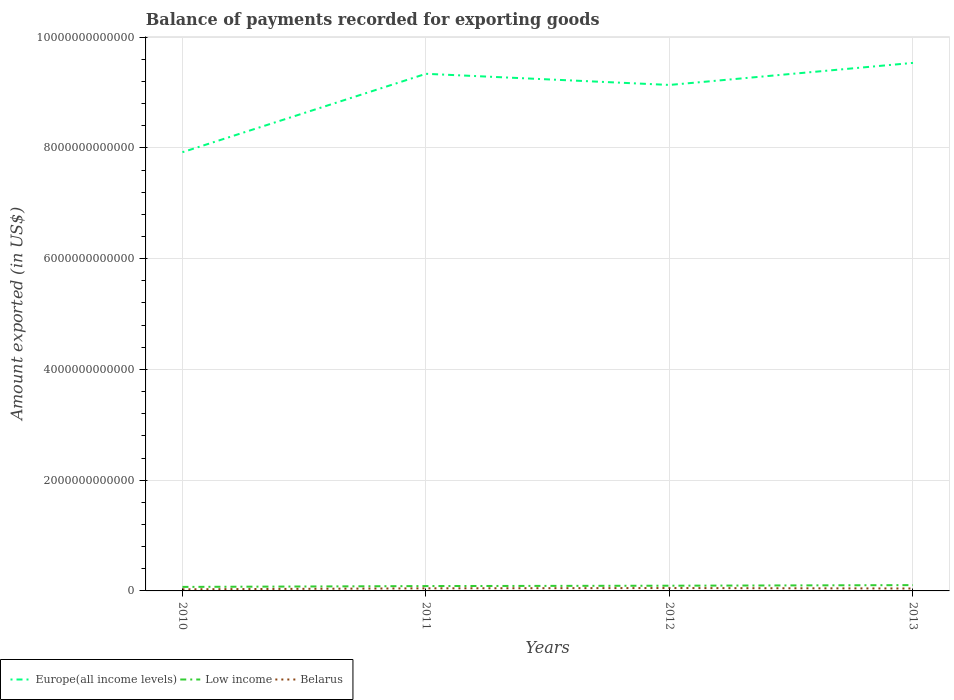How many different coloured lines are there?
Offer a very short reply. 3. Does the line corresponding to Low income intersect with the line corresponding to Europe(all income levels)?
Make the answer very short. No. Is the number of lines equal to the number of legend labels?
Make the answer very short. Yes. Across all years, what is the maximum amount exported in Europe(all income levels)?
Offer a very short reply. 7.92e+12. What is the total amount exported in Belarus in the graph?
Make the answer very short. -1.47e+1. What is the difference between the highest and the second highest amount exported in Europe(all income levels)?
Keep it short and to the point. 1.61e+12. What is the difference between the highest and the lowest amount exported in Low income?
Provide a short and direct response. 2. Is the amount exported in Belarus strictly greater than the amount exported in Europe(all income levels) over the years?
Provide a succinct answer. Yes. How many years are there in the graph?
Offer a terse response. 4. What is the difference between two consecutive major ticks on the Y-axis?
Keep it short and to the point. 2.00e+12. Are the values on the major ticks of Y-axis written in scientific E-notation?
Provide a succinct answer. No. Does the graph contain any zero values?
Your answer should be compact. No. Does the graph contain grids?
Provide a short and direct response. Yes. Where does the legend appear in the graph?
Provide a short and direct response. Bottom left. How many legend labels are there?
Make the answer very short. 3. How are the legend labels stacked?
Ensure brevity in your answer.  Horizontal. What is the title of the graph?
Make the answer very short. Balance of payments recorded for exporting goods. What is the label or title of the X-axis?
Provide a short and direct response. Years. What is the label or title of the Y-axis?
Your answer should be compact. Amount exported (in US$). What is the Amount exported (in US$) in Europe(all income levels) in 2010?
Provide a succinct answer. 7.92e+12. What is the Amount exported (in US$) of Low income in 2010?
Ensure brevity in your answer.  7.24e+1. What is the Amount exported (in US$) in Belarus in 2010?
Your answer should be very brief. 2.93e+1. What is the Amount exported (in US$) in Europe(all income levels) in 2011?
Your answer should be compact. 9.34e+12. What is the Amount exported (in US$) in Low income in 2011?
Give a very brief answer. 8.77e+1. What is the Amount exported (in US$) of Belarus in 2011?
Your response must be concise. 4.65e+1. What is the Amount exported (in US$) of Europe(all income levels) in 2012?
Give a very brief answer. 9.14e+12. What is the Amount exported (in US$) in Low income in 2012?
Give a very brief answer. 9.42e+1. What is the Amount exported (in US$) of Belarus in 2012?
Your answer should be compact. 5.19e+1. What is the Amount exported (in US$) of Europe(all income levels) in 2013?
Offer a very short reply. 9.54e+12. What is the Amount exported (in US$) of Low income in 2013?
Provide a succinct answer. 1.05e+11. What is the Amount exported (in US$) in Belarus in 2013?
Offer a very short reply. 4.40e+1. Across all years, what is the maximum Amount exported (in US$) in Europe(all income levels)?
Your response must be concise. 9.54e+12. Across all years, what is the maximum Amount exported (in US$) in Low income?
Your answer should be compact. 1.05e+11. Across all years, what is the maximum Amount exported (in US$) in Belarus?
Provide a succinct answer. 5.19e+1. Across all years, what is the minimum Amount exported (in US$) in Europe(all income levels)?
Give a very brief answer. 7.92e+12. Across all years, what is the minimum Amount exported (in US$) in Low income?
Your answer should be very brief. 7.24e+1. Across all years, what is the minimum Amount exported (in US$) of Belarus?
Your response must be concise. 2.93e+1. What is the total Amount exported (in US$) in Europe(all income levels) in the graph?
Keep it short and to the point. 3.59e+13. What is the total Amount exported (in US$) of Low income in the graph?
Your response must be concise. 3.59e+11. What is the total Amount exported (in US$) of Belarus in the graph?
Keep it short and to the point. 1.72e+11. What is the difference between the Amount exported (in US$) in Europe(all income levels) in 2010 and that in 2011?
Your answer should be compact. -1.42e+12. What is the difference between the Amount exported (in US$) in Low income in 2010 and that in 2011?
Ensure brevity in your answer.  -1.53e+1. What is the difference between the Amount exported (in US$) of Belarus in 2010 and that in 2011?
Ensure brevity in your answer.  -1.72e+1. What is the difference between the Amount exported (in US$) in Europe(all income levels) in 2010 and that in 2012?
Your answer should be very brief. -1.21e+12. What is the difference between the Amount exported (in US$) in Low income in 2010 and that in 2012?
Provide a short and direct response. -2.17e+1. What is the difference between the Amount exported (in US$) in Belarus in 2010 and that in 2012?
Keep it short and to the point. -2.26e+1. What is the difference between the Amount exported (in US$) in Europe(all income levels) in 2010 and that in 2013?
Keep it short and to the point. -1.61e+12. What is the difference between the Amount exported (in US$) of Low income in 2010 and that in 2013?
Keep it short and to the point. -3.23e+1. What is the difference between the Amount exported (in US$) of Belarus in 2010 and that in 2013?
Your answer should be very brief. -1.47e+1. What is the difference between the Amount exported (in US$) of Europe(all income levels) in 2011 and that in 2012?
Provide a succinct answer. 2.01e+11. What is the difference between the Amount exported (in US$) in Low income in 2011 and that in 2012?
Make the answer very short. -6.43e+09. What is the difference between the Amount exported (in US$) of Belarus in 2011 and that in 2012?
Ensure brevity in your answer.  -5.35e+09. What is the difference between the Amount exported (in US$) in Europe(all income levels) in 2011 and that in 2013?
Keep it short and to the point. -1.97e+11. What is the difference between the Amount exported (in US$) of Low income in 2011 and that in 2013?
Offer a terse response. -1.70e+1. What is the difference between the Amount exported (in US$) in Belarus in 2011 and that in 2013?
Your response must be concise. 2.49e+09. What is the difference between the Amount exported (in US$) in Europe(all income levels) in 2012 and that in 2013?
Keep it short and to the point. -3.98e+11. What is the difference between the Amount exported (in US$) of Low income in 2012 and that in 2013?
Your answer should be very brief. -1.06e+1. What is the difference between the Amount exported (in US$) in Belarus in 2012 and that in 2013?
Provide a short and direct response. 7.84e+09. What is the difference between the Amount exported (in US$) in Europe(all income levels) in 2010 and the Amount exported (in US$) in Low income in 2011?
Keep it short and to the point. 7.83e+12. What is the difference between the Amount exported (in US$) of Europe(all income levels) in 2010 and the Amount exported (in US$) of Belarus in 2011?
Keep it short and to the point. 7.88e+12. What is the difference between the Amount exported (in US$) in Low income in 2010 and the Amount exported (in US$) in Belarus in 2011?
Ensure brevity in your answer.  2.59e+1. What is the difference between the Amount exported (in US$) of Europe(all income levels) in 2010 and the Amount exported (in US$) of Low income in 2012?
Offer a very short reply. 7.83e+12. What is the difference between the Amount exported (in US$) in Europe(all income levels) in 2010 and the Amount exported (in US$) in Belarus in 2012?
Keep it short and to the point. 7.87e+12. What is the difference between the Amount exported (in US$) of Low income in 2010 and the Amount exported (in US$) of Belarus in 2012?
Your answer should be very brief. 2.05e+1. What is the difference between the Amount exported (in US$) of Europe(all income levels) in 2010 and the Amount exported (in US$) of Low income in 2013?
Your answer should be very brief. 7.82e+12. What is the difference between the Amount exported (in US$) of Europe(all income levels) in 2010 and the Amount exported (in US$) of Belarus in 2013?
Ensure brevity in your answer.  7.88e+12. What is the difference between the Amount exported (in US$) of Low income in 2010 and the Amount exported (in US$) of Belarus in 2013?
Make the answer very short. 2.84e+1. What is the difference between the Amount exported (in US$) of Europe(all income levels) in 2011 and the Amount exported (in US$) of Low income in 2012?
Give a very brief answer. 9.24e+12. What is the difference between the Amount exported (in US$) in Europe(all income levels) in 2011 and the Amount exported (in US$) in Belarus in 2012?
Offer a terse response. 9.29e+12. What is the difference between the Amount exported (in US$) of Low income in 2011 and the Amount exported (in US$) of Belarus in 2012?
Make the answer very short. 3.59e+1. What is the difference between the Amount exported (in US$) of Europe(all income levels) in 2011 and the Amount exported (in US$) of Low income in 2013?
Your response must be concise. 9.23e+12. What is the difference between the Amount exported (in US$) of Europe(all income levels) in 2011 and the Amount exported (in US$) of Belarus in 2013?
Ensure brevity in your answer.  9.29e+12. What is the difference between the Amount exported (in US$) in Low income in 2011 and the Amount exported (in US$) in Belarus in 2013?
Give a very brief answer. 4.37e+1. What is the difference between the Amount exported (in US$) of Europe(all income levels) in 2012 and the Amount exported (in US$) of Low income in 2013?
Your answer should be very brief. 9.03e+12. What is the difference between the Amount exported (in US$) of Europe(all income levels) in 2012 and the Amount exported (in US$) of Belarus in 2013?
Your answer should be very brief. 9.09e+12. What is the difference between the Amount exported (in US$) in Low income in 2012 and the Amount exported (in US$) in Belarus in 2013?
Make the answer very short. 5.01e+1. What is the average Amount exported (in US$) of Europe(all income levels) per year?
Keep it short and to the point. 8.98e+12. What is the average Amount exported (in US$) in Low income per year?
Your answer should be very brief. 8.98e+1. What is the average Amount exported (in US$) of Belarus per year?
Ensure brevity in your answer.  4.29e+1. In the year 2010, what is the difference between the Amount exported (in US$) in Europe(all income levels) and Amount exported (in US$) in Low income?
Your answer should be compact. 7.85e+12. In the year 2010, what is the difference between the Amount exported (in US$) of Europe(all income levels) and Amount exported (in US$) of Belarus?
Give a very brief answer. 7.89e+12. In the year 2010, what is the difference between the Amount exported (in US$) in Low income and Amount exported (in US$) in Belarus?
Provide a succinct answer. 4.31e+1. In the year 2011, what is the difference between the Amount exported (in US$) of Europe(all income levels) and Amount exported (in US$) of Low income?
Offer a terse response. 9.25e+12. In the year 2011, what is the difference between the Amount exported (in US$) of Europe(all income levels) and Amount exported (in US$) of Belarus?
Offer a terse response. 9.29e+12. In the year 2011, what is the difference between the Amount exported (in US$) of Low income and Amount exported (in US$) of Belarus?
Your answer should be compact. 4.12e+1. In the year 2012, what is the difference between the Amount exported (in US$) of Europe(all income levels) and Amount exported (in US$) of Low income?
Offer a terse response. 9.04e+12. In the year 2012, what is the difference between the Amount exported (in US$) in Europe(all income levels) and Amount exported (in US$) in Belarus?
Provide a short and direct response. 9.09e+12. In the year 2012, what is the difference between the Amount exported (in US$) in Low income and Amount exported (in US$) in Belarus?
Your response must be concise. 4.23e+1. In the year 2013, what is the difference between the Amount exported (in US$) of Europe(all income levels) and Amount exported (in US$) of Low income?
Provide a short and direct response. 9.43e+12. In the year 2013, what is the difference between the Amount exported (in US$) in Europe(all income levels) and Amount exported (in US$) in Belarus?
Provide a succinct answer. 9.49e+12. In the year 2013, what is the difference between the Amount exported (in US$) of Low income and Amount exported (in US$) of Belarus?
Provide a short and direct response. 6.07e+1. What is the ratio of the Amount exported (in US$) of Europe(all income levels) in 2010 to that in 2011?
Your answer should be very brief. 0.85. What is the ratio of the Amount exported (in US$) of Low income in 2010 to that in 2011?
Provide a succinct answer. 0.83. What is the ratio of the Amount exported (in US$) of Belarus in 2010 to that in 2011?
Offer a terse response. 0.63. What is the ratio of the Amount exported (in US$) in Europe(all income levels) in 2010 to that in 2012?
Keep it short and to the point. 0.87. What is the ratio of the Amount exported (in US$) in Low income in 2010 to that in 2012?
Give a very brief answer. 0.77. What is the ratio of the Amount exported (in US$) in Belarus in 2010 to that in 2012?
Make the answer very short. 0.56. What is the ratio of the Amount exported (in US$) of Europe(all income levels) in 2010 to that in 2013?
Ensure brevity in your answer.  0.83. What is the ratio of the Amount exported (in US$) in Low income in 2010 to that in 2013?
Your answer should be very brief. 0.69. What is the ratio of the Amount exported (in US$) of Belarus in 2010 to that in 2013?
Ensure brevity in your answer.  0.67. What is the ratio of the Amount exported (in US$) in Europe(all income levels) in 2011 to that in 2012?
Provide a succinct answer. 1.02. What is the ratio of the Amount exported (in US$) of Low income in 2011 to that in 2012?
Keep it short and to the point. 0.93. What is the ratio of the Amount exported (in US$) in Belarus in 2011 to that in 2012?
Provide a short and direct response. 0.9. What is the ratio of the Amount exported (in US$) of Europe(all income levels) in 2011 to that in 2013?
Make the answer very short. 0.98. What is the ratio of the Amount exported (in US$) in Low income in 2011 to that in 2013?
Your answer should be compact. 0.84. What is the ratio of the Amount exported (in US$) of Belarus in 2011 to that in 2013?
Give a very brief answer. 1.06. What is the ratio of the Amount exported (in US$) in Europe(all income levels) in 2012 to that in 2013?
Ensure brevity in your answer.  0.96. What is the ratio of the Amount exported (in US$) of Low income in 2012 to that in 2013?
Your response must be concise. 0.9. What is the ratio of the Amount exported (in US$) of Belarus in 2012 to that in 2013?
Provide a succinct answer. 1.18. What is the difference between the highest and the second highest Amount exported (in US$) in Europe(all income levels)?
Keep it short and to the point. 1.97e+11. What is the difference between the highest and the second highest Amount exported (in US$) in Low income?
Provide a succinct answer. 1.06e+1. What is the difference between the highest and the second highest Amount exported (in US$) in Belarus?
Provide a short and direct response. 5.35e+09. What is the difference between the highest and the lowest Amount exported (in US$) of Europe(all income levels)?
Make the answer very short. 1.61e+12. What is the difference between the highest and the lowest Amount exported (in US$) in Low income?
Keep it short and to the point. 3.23e+1. What is the difference between the highest and the lowest Amount exported (in US$) in Belarus?
Offer a terse response. 2.26e+1. 